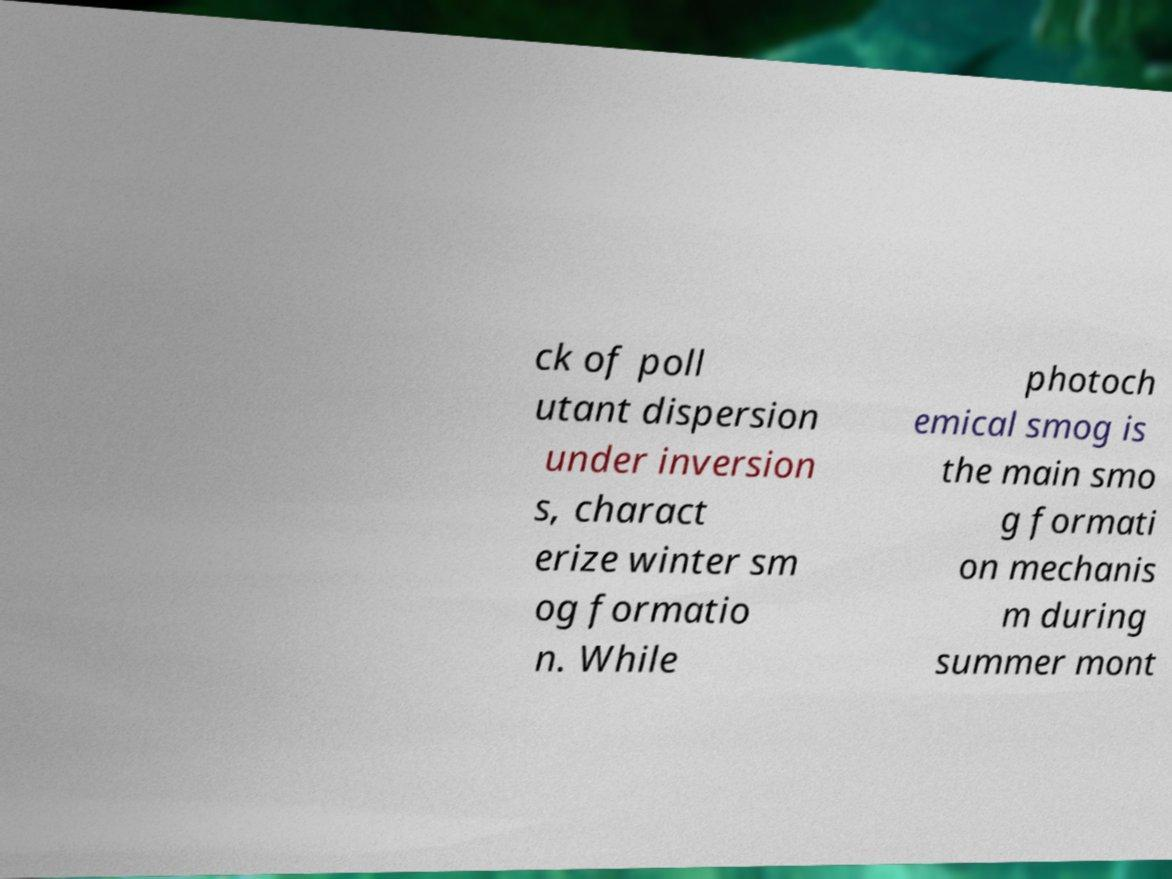Can you read and provide the text displayed in the image?This photo seems to have some interesting text. Can you extract and type it out for me? ck of poll utant dispersion under inversion s, charact erize winter sm og formatio n. While photoch emical smog is the main smo g formati on mechanis m during summer mont 